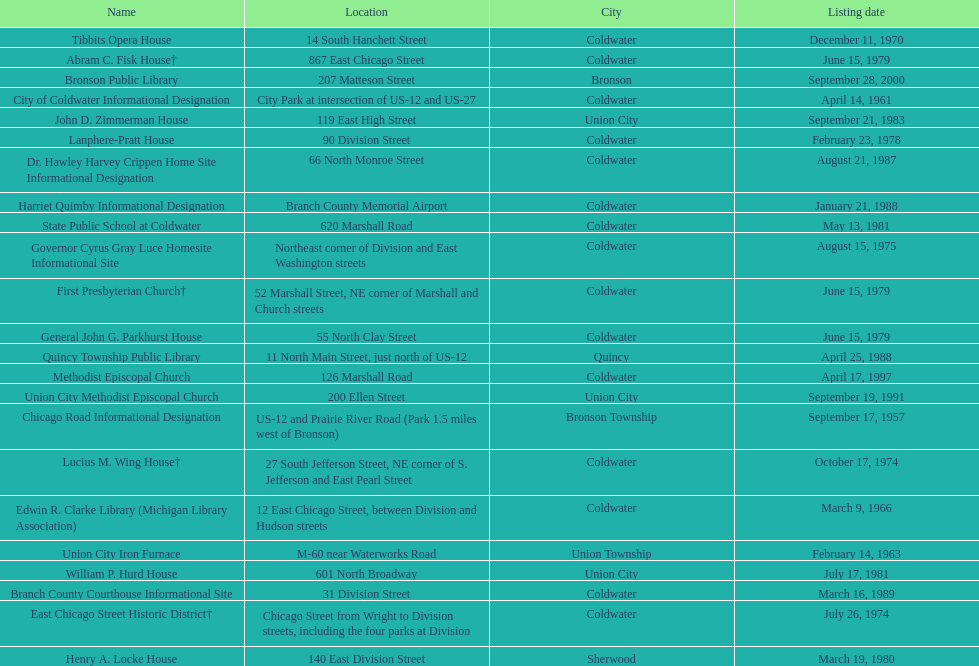How many sites are in coldwater? 15. 